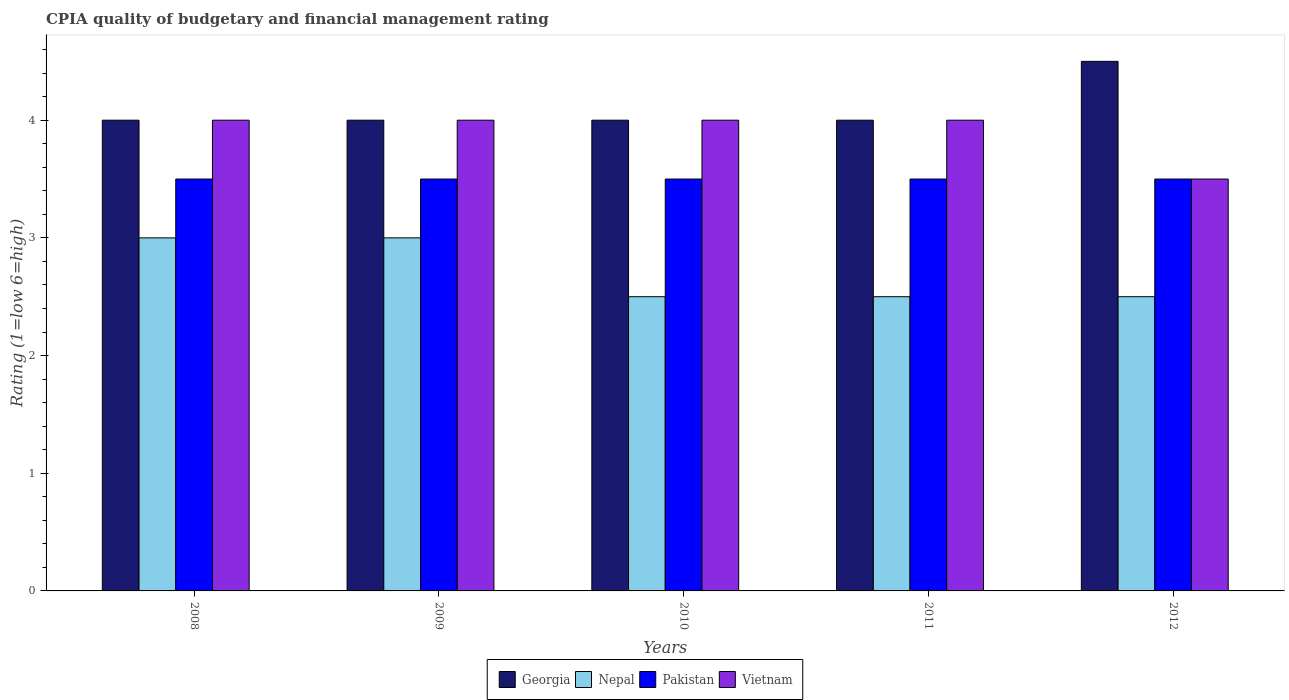Are the number of bars per tick equal to the number of legend labels?
Make the answer very short. Yes. Are the number of bars on each tick of the X-axis equal?
Your response must be concise. Yes. What is the CPIA rating in Nepal in 2011?
Provide a short and direct response. 2.5. Across all years, what is the maximum CPIA rating in Vietnam?
Make the answer very short. 4. Across all years, what is the minimum CPIA rating in Vietnam?
Provide a short and direct response. 3.5. In which year was the CPIA rating in Georgia minimum?
Provide a short and direct response. 2008. In the year 2008, what is the difference between the CPIA rating in Nepal and CPIA rating in Georgia?
Provide a short and direct response. -1. What is the ratio of the CPIA rating in Pakistan in 2011 to that in 2012?
Give a very brief answer. 1. Is the CPIA rating in Vietnam in 2008 less than that in 2010?
Offer a very short reply. No. What is the difference between the highest and the lowest CPIA rating in Vietnam?
Your response must be concise. 0.5. In how many years, is the CPIA rating in Vietnam greater than the average CPIA rating in Vietnam taken over all years?
Offer a very short reply. 4. What does the 4th bar from the left in 2011 represents?
Your answer should be very brief. Vietnam. What does the 4th bar from the right in 2012 represents?
Provide a succinct answer. Georgia. How many years are there in the graph?
Your answer should be compact. 5. Are the values on the major ticks of Y-axis written in scientific E-notation?
Provide a succinct answer. No. Where does the legend appear in the graph?
Your answer should be very brief. Bottom center. How many legend labels are there?
Offer a terse response. 4. What is the title of the graph?
Provide a succinct answer. CPIA quality of budgetary and financial management rating. What is the label or title of the Y-axis?
Keep it short and to the point. Rating (1=low 6=high). What is the Rating (1=low 6=high) in Georgia in 2008?
Ensure brevity in your answer.  4. What is the Rating (1=low 6=high) in Nepal in 2008?
Your answer should be compact. 3. What is the Rating (1=low 6=high) in Pakistan in 2009?
Offer a terse response. 3.5. What is the Rating (1=low 6=high) in Vietnam in 2009?
Your response must be concise. 4. What is the Rating (1=low 6=high) in Nepal in 2010?
Your answer should be very brief. 2.5. What is the Rating (1=low 6=high) in Vietnam in 2010?
Your answer should be compact. 4. What is the Rating (1=low 6=high) in Vietnam in 2011?
Provide a short and direct response. 4. What is the Rating (1=low 6=high) in Georgia in 2012?
Your answer should be compact. 4.5. What is the Rating (1=low 6=high) in Nepal in 2012?
Give a very brief answer. 2.5. What is the Rating (1=low 6=high) of Pakistan in 2012?
Keep it short and to the point. 3.5. What is the Rating (1=low 6=high) of Vietnam in 2012?
Provide a succinct answer. 3.5. Across all years, what is the maximum Rating (1=low 6=high) in Nepal?
Provide a short and direct response. 3. Across all years, what is the maximum Rating (1=low 6=high) in Pakistan?
Your answer should be compact. 3.5. Across all years, what is the minimum Rating (1=low 6=high) in Pakistan?
Provide a short and direct response. 3.5. Across all years, what is the minimum Rating (1=low 6=high) of Vietnam?
Ensure brevity in your answer.  3.5. What is the total Rating (1=low 6=high) in Georgia in the graph?
Offer a very short reply. 20.5. What is the total Rating (1=low 6=high) of Nepal in the graph?
Provide a short and direct response. 13.5. What is the total Rating (1=low 6=high) in Pakistan in the graph?
Provide a succinct answer. 17.5. What is the difference between the Rating (1=low 6=high) of Nepal in 2008 and that in 2009?
Your answer should be very brief. 0. What is the difference between the Rating (1=low 6=high) of Georgia in 2008 and that in 2010?
Your answer should be compact. 0. What is the difference between the Rating (1=low 6=high) of Vietnam in 2008 and that in 2010?
Your answer should be compact. 0. What is the difference between the Rating (1=low 6=high) in Georgia in 2008 and that in 2011?
Your answer should be very brief. 0. What is the difference between the Rating (1=low 6=high) in Georgia in 2008 and that in 2012?
Your answer should be compact. -0.5. What is the difference between the Rating (1=low 6=high) of Nepal in 2008 and that in 2012?
Offer a terse response. 0.5. What is the difference between the Rating (1=low 6=high) in Pakistan in 2008 and that in 2012?
Make the answer very short. 0. What is the difference between the Rating (1=low 6=high) of Vietnam in 2008 and that in 2012?
Your answer should be compact. 0.5. What is the difference between the Rating (1=low 6=high) of Nepal in 2009 and that in 2010?
Provide a succinct answer. 0.5. What is the difference between the Rating (1=low 6=high) of Vietnam in 2009 and that in 2010?
Provide a succinct answer. 0. What is the difference between the Rating (1=low 6=high) of Georgia in 2009 and that in 2011?
Offer a very short reply. 0. What is the difference between the Rating (1=low 6=high) in Pakistan in 2009 and that in 2011?
Keep it short and to the point. 0. What is the difference between the Rating (1=low 6=high) of Vietnam in 2009 and that in 2011?
Your answer should be compact. 0. What is the difference between the Rating (1=low 6=high) in Georgia in 2009 and that in 2012?
Your answer should be compact. -0.5. What is the difference between the Rating (1=low 6=high) of Vietnam in 2009 and that in 2012?
Your answer should be compact. 0.5. What is the difference between the Rating (1=low 6=high) of Vietnam in 2010 and that in 2011?
Your response must be concise. 0. What is the difference between the Rating (1=low 6=high) in Nepal in 2010 and that in 2012?
Provide a succinct answer. 0. What is the difference between the Rating (1=low 6=high) of Vietnam in 2010 and that in 2012?
Offer a terse response. 0.5. What is the difference between the Rating (1=low 6=high) of Georgia in 2011 and that in 2012?
Provide a short and direct response. -0.5. What is the difference between the Rating (1=low 6=high) in Georgia in 2008 and the Rating (1=low 6=high) in Nepal in 2009?
Ensure brevity in your answer.  1. What is the difference between the Rating (1=low 6=high) of Georgia in 2008 and the Rating (1=low 6=high) of Pakistan in 2009?
Make the answer very short. 0.5. What is the difference between the Rating (1=low 6=high) in Georgia in 2008 and the Rating (1=low 6=high) in Vietnam in 2009?
Offer a very short reply. 0. What is the difference between the Rating (1=low 6=high) in Nepal in 2008 and the Rating (1=low 6=high) in Pakistan in 2009?
Ensure brevity in your answer.  -0.5. What is the difference between the Rating (1=low 6=high) in Nepal in 2008 and the Rating (1=low 6=high) in Vietnam in 2009?
Make the answer very short. -1. What is the difference between the Rating (1=low 6=high) in Georgia in 2008 and the Rating (1=low 6=high) in Nepal in 2010?
Ensure brevity in your answer.  1.5. What is the difference between the Rating (1=low 6=high) in Georgia in 2008 and the Rating (1=low 6=high) in Pakistan in 2010?
Ensure brevity in your answer.  0.5. What is the difference between the Rating (1=low 6=high) of Georgia in 2008 and the Rating (1=low 6=high) of Vietnam in 2010?
Offer a very short reply. 0. What is the difference between the Rating (1=low 6=high) of Nepal in 2008 and the Rating (1=low 6=high) of Pakistan in 2010?
Make the answer very short. -0.5. What is the difference between the Rating (1=low 6=high) in Pakistan in 2008 and the Rating (1=low 6=high) in Vietnam in 2010?
Give a very brief answer. -0.5. What is the difference between the Rating (1=low 6=high) of Georgia in 2008 and the Rating (1=low 6=high) of Vietnam in 2011?
Keep it short and to the point. 0. What is the difference between the Rating (1=low 6=high) in Nepal in 2008 and the Rating (1=low 6=high) in Vietnam in 2011?
Your answer should be very brief. -1. What is the difference between the Rating (1=low 6=high) of Pakistan in 2008 and the Rating (1=low 6=high) of Vietnam in 2011?
Offer a very short reply. -0.5. What is the difference between the Rating (1=low 6=high) of Nepal in 2008 and the Rating (1=low 6=high) of Pakistan in 2012?
Make the answer very short. -0.5. What is the difference between the Rating (1=low 6=high) in Nepal in 2008 and the Rating (1=low 6=high) in Vietnam in 2012?
Your answer should be compact. -0.5. What is the difference between the Rating (1=low 6=high) in Georgia in 2009 and the Rating (1=low 6=high) in Nepal in 2010?
Your response must be concise. 1.5. What is the difference between the Rating (1=low 6=high) of Georgia in 2009 and the Rating (1=low 6=high) of Pakistan in 2010?
Keep it short and to the point. 0.5. What is the difference between the Rating (1=low 6=high) in Nepal in 2009 and the Rating (1=low 6=high) in Pakistan in 2010?
Keep it short and to the point. -0.5. What is the difference between the Rating (1=low 6=high) in Nepal in 2009 and the Rating (1=low 6=high) in Vietnam in 2010?
Provide a short and direct response. -1. What is the difference between the Rating (1=low 6=high) in Georgia in 2009 and the Rating (1=low 6=high) in Nepal in 2011?
Ensure brevity in your answer.  1.5. What is the difference between the Rating (1=low 6=high) of Georgia in 2009 and the Rating (1=low 6=high) of Pakistan in 2011?
Keep it short and to the point. 0.5. What is the difference between the Rating (1=low 6=high) of Georgia in 2009 and the Rating (1=low 6=high) of Vietnam in 2011?
Your response must be concise. 0. What is the difference between the Rating (1=low 6=high) of Nepal in 2009 and the Rating (1=low 6=high) of Vietnam in 2011?
Offer a very short reply. -1. What is the difference between the Rating (1=low 6=high) in Pakistan in 2009 and the Rating (1=low 6=high) in Vietnam in 2011?
Offer a very short reply. -0.5. What is the difference between the Rating (1=low 6=high) of Georgia in 2009 and the Rating (1=low 6=high) of Pakistan in 2012?
Your answer should be compact. 0.5. What is the difference between the Rating (1=low 6=high) in Georgia in 2009 and the Rating (1=low 6=high) in Vietnam in 2012?
Your answer should be compact. 0.5. What is the difference between the Rating (1=low 6=high) of Nepal in 2009 and the Rating (1=low 6=high) of Pakistan in 2012?
Your answer should be very brief. -0.5. What is the difference between the Rating (1=low 6=high) of Nepal in 2009 and the Rating (1=low 6=high) of Vietnam in 2012?
Offer a very short reply. -0.5. What is the difference between the Rating (1=low 6=high) of Georgia in 2010 and the Rating (1=low 6=high) of Pakistan in 2011?
Your answer should be compact. 0.5. What is the difference between the Rating (1=low 6=high) in Georgia in 2010 and the Rating (1=low 6=high) in Vietnam in 2011?
Offer a terse response. 0. What is the difference between the Rating (1=low 6=high) in Nepal in 2010 and the Rating (1=low 6=high) in Vietnam in 2011?
Give a very brief answer. -1.5. What is the difference between the Rating (1=low 6=high) of Georgia in 2010 and the Rating (1=low 6=high) of Nepal in 2012?
Ensure brevity in your answer.  1.5. What is the difference between the Rating (1=low 6=high) in Georgia in 2010 and the Rating (1=low 6=high) in Pakistan in 2012?
Offer a very short reply. 0.5. What is the difference between the Rating (1=low 6=high) of Georgia in 2010 and the Rating (1=low 6=high) of Vietnam in 2012?
Ensure brevity in your answer.  0.5. What is the difference between the Rating (1=low 6=high) of Nepal in 2010 and the Rating (1=low 6=high) of Pakistan in 2012?
Offer a very short reply. -1. What is the difference between the Rating (1=low 6=high) of Pakistan in 2010 and the Rating (1=low 6=high) of Vietnam in 2012?
Provide a short and direct response. 0. What is the difference between the Rating (1=low 6=high) in Georgia in 2011 and the Rating (1=low 6=high) in Nepal in 2012?
Offer a terse response. 1.5. What is the difference between the Rating (1=low 6=high) in Georgia in 2011 and the Rating (1=low 6=high) in Vietnam in 2012?
Your response must be concise. 0.5. What is the difference between the Rating (1=low 6=high) of Pakistan in 2011 and the Rating (1=low 6=high) of Vietnam in 2012?
Provide a succinct answer. 0. What is the average Rating (1=low 6=high) of Georgia per year?
Your answer should be very brief. 4.1. What is the average Rating (1=low 6=high) in Nepal per year?
Provide a succinct answer. 2.7. What is the average Rating (1=low 6=high) of Vietnam per year?
Your answer should be very brief. 3.9. In the year 2008, what is the difference between the Rating (1=low 6=high) in Georgia and Rating (1=low 6=high) in Nepal?
Give a very brief answer. 1. In the year 2008, what is the difference between the Rating (1=low 6=high) of Georgia and Rating (1=low 6=high) of Pakistan?
Your answer should be very brief. 0.5. In the year 2008, what is the difference between the Rating (1=low 6=high) of Nepal and Rating (1=low 6=high) of Pakistan?
Offer a terse response. -0.5. In the year 2008, what is the difference between the Rating (1=low 6=high) of Nepal and Rating (1=low 6=high) of Vietnam?
Keep it short and to the point. -1. In the year 2008, what is the difference between the Rating (1=low 6=high) of Pakistan and Rating (1=low 6=high) of Vietnam?
Keep it short and to the point. -0.5. In the year 2009, what is the difference between the Rating (1=low 6=high) in Georgia and Rating (1=low 6=high) in Pakistan?
Keep it short and to the point. 0.5. In the year 2009, what is the difference between the Rating (1=low 6=high) in Nepal and Rating (1=low 6=high) in Pakistan?
Your answer should be very brief. -0.5. In the year 2010, what is the difference between the Rating (1=low 6=high) in Georgia and Rating (1=low 6=high) in Nepal?
Your answer should be very brief. 1.5. In the year 2010, what is the difference between the Rating (1=low 6=high) in Nepal and Rating (1=low 6=high) in Vietnam?
Provide a succinct answer. -1.5. In the year 2010, what is the difference between the Rating (1=low 6=high) in Pakistan and Rating (1=low 6=high) in Vietnam?
Offer a very short reply. -0.5. In the year 2011, what is the difference between the Rating (1=low 6=high) of Georgia and Rating (1=low 6=high) of Nepal?
Give a very brief answer. 1.5. In the year 2011, what is the difference between the Rating (1=low 6=high) of Georgia and Rating (1=low 6=high) of Vietnam?
Provide a short and direct response. 0. In the year 2011, what is the difference between the Rating (1=low 6=high) in Nepal and Rating (1=low 6=high) in Pakistan?
Offer a very short reply. -1. In the year 2011, what is the difference between the Rating (1=low 6=high) in Pakistan and Rating (1=low 6=high) in Vietnam?
Offer a very short reply. -0.5. In the year 2012, what is the difference between the Rating (1=low 6=high) in Georgia and Rating (1=low 6=high) in Nepal?
Provide a succinct answer. 2. In the year 2012, what is the difference between the Rating (1=low 6=high) of Nepal and Rating (1=low 6=high) of Pakistan?
Give a very brief answer. -1. What is the ratio of the Rating (1=low 6=high) of Georgia in 2008 to that in 2009?
Offer a very short reply. 1. What is the ratio of the Rating (1=low 6=high) in Nepal in 2008 to that in 2009?
Your response must be concise. 1. What is the ratio of the Rating (1=low 6=high) in Pakistan in 2008 to that in 2009?
Keep it short and to the point. 1. What is the ratio of the Rating (1=low 6=high) of Vietnam in 2008 to that in 2009?
Keep it short and to the point. 1. What is the ratio of the Rating (1=low 6=high) of Nepal in 2008 to that in 2010?
Give a very brief answer. 1.2. What is the ratio of the Rating (1=low 6=high) in Nepal in 2008 to that in 2011?
Give a very brief answer. 1.2. What is the ratio of the Rating (1=low 6=high) of Vietnam in 2008 to that in 2012?
Give a very brief answer. 1.14. What is the ratio of the Rating (1=low 6=high) in Pakistan in 2009 to that in 2010?
Ensure brevity in your answer.  1. What is the ratio of the Rating (1=low 6=high) in Nepal in 2009 to that in 2011?
Your answer should be very brief. 1.2. What is the ratio of the Rating (1=low 6=high) of Pakistan in 2009 to that in 2011?
Your answer should be very brief. 1. What is the ratio of the Rating (1=low 6=high) of Nepal in 2009 to that in 2012?
Offer a very short reply. 1.2. What is the ratio of the Rating (1=low 6=high) of Vietnam in 2009 to that in 2012?
Provide a succinct answer. 1.14. What is the ratio of the Rating (1=low 6=high) in Pakistan in 2010 to that in 2011?
Keep it short and to the point. 1. What is the ratio of the Rating (1=low 6=high) in Georgia in 2010 to that in 2012?
Your answer should be compact. 0.89. What is the ratio of the Rating (1=low 6=high) of Vietnam in 2010 to that in 2012?
Your response must be concise. 1.14. What is the difference between the highest and the second highest Rating (1=low 6=high) of Georgia?
Provide a succinct answer. 0.5. What is the difference between the highest and the second highest Rating (1=low 6=high) in Nepal?
Keep it short and to the point. 0. What is the difference between the highest and the second highest Rating (1=low 6=high) in Vietnam?
Your answer should be compact. 0. What is the difference between the highest and the lowest Rating (1=low 6=high) in Nepal?
Offer a very short reply. 0.5. What is the difference between the highest and the lowest Rating (1=low 6=high) of Vietnam?
Your answer should be compact. 0.5. 